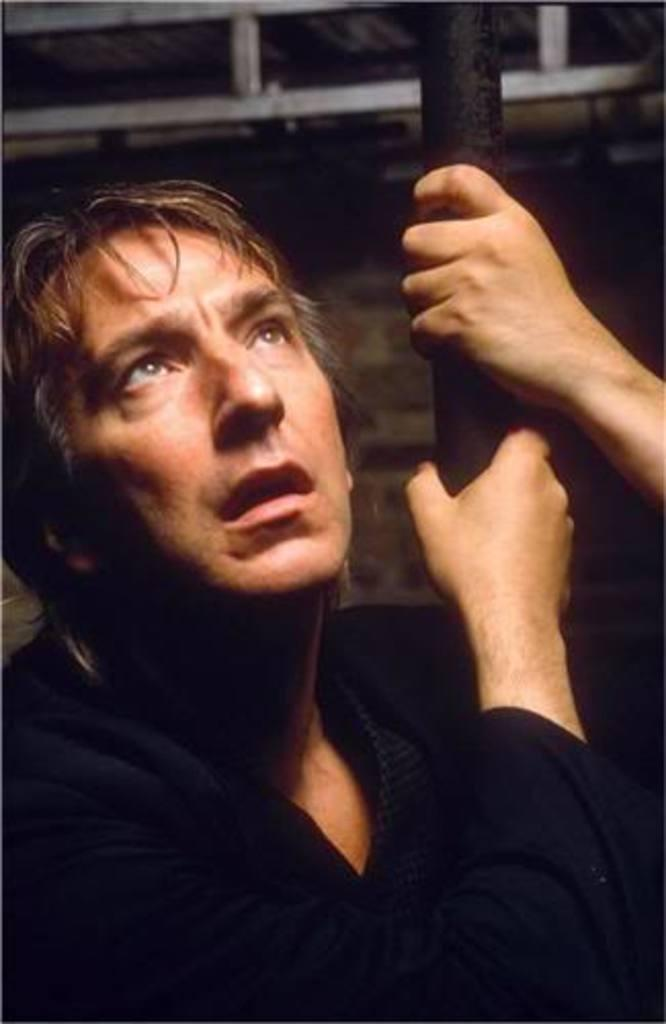Who is present in the image? There is a man in the image. What is the man holding in the image? The man is holding a pole. What can be seen in the background of the image? There is a wall in the background of the image. How many kittens are sitting on the man's shoulders in the image? There are no kittens present in the image. What color are the eggs that the man is holding in the image? The man is not holding any eggs in the image. 